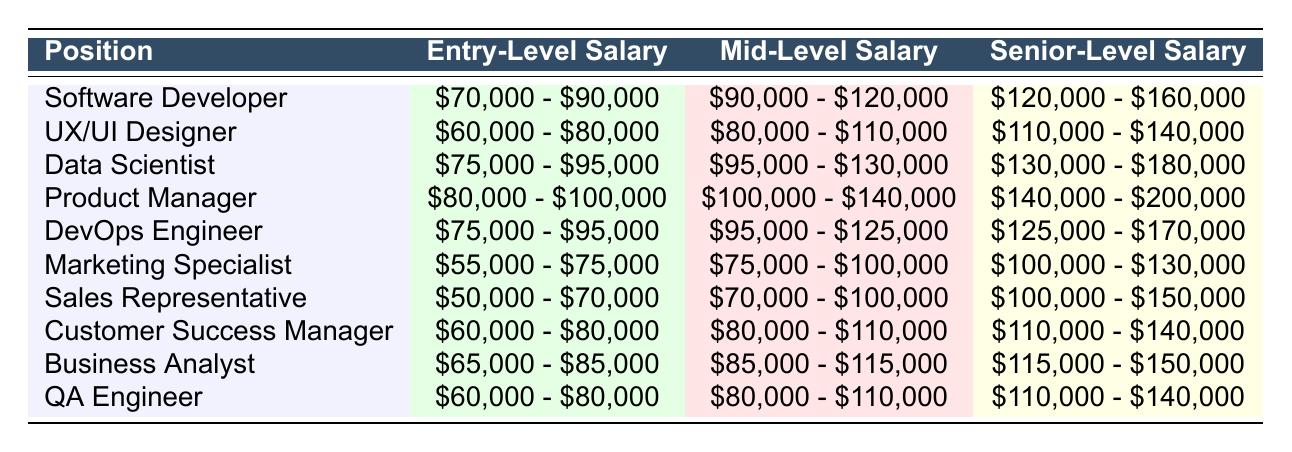What is the entry-level salary range for a Data Scientist? The table lists the salaries for each position. For Data Scientist, the entry-level salary is indicated as $75,000 - $95,000.
Answer: $75,000 - $95,000 Which position has the highest senior-level salary range? By examining the senior-level salary ranges, Product Manager has the highest range at $140,000 - $200,000.
Answer: Product Manager What is the difference in mid-level salary between a Software Developer and a Marketing Specialist? The mid-level salary for a Software Developer is $90,000 - $120,000, and for a Marketing Specialist, it is $75,000 - $100,000. The difference between the upper limits is $120,000 - $100,000 = $20,000.
Answer: $20,000 Is the entry-level salary of a Sales Representative higher than that of a Marketing Specialist? The entry-level salary for a Sales Representative is $50,000 - $70,000 and for a Marketing Specialist, it is $55,000 - $75,000. Since $50,000 - $70,000 is lower than $55,000 - $75,000, the answer is no.
Answer: No What is the average salary range of a QA Engineer across all levels? For QA Engineer, the entry-level is $60,000 - $80,000, mid-level is $80,000 - $110,000, and senior-level is $110,000 - $140,000. The average of the low ends is ($60,000 + $80,000 + $110,000)/3 = $83,333.33 and for the high ends is ($80,000 + $110,000 + $140,000)/3 = $110,000. Therefore, the average range is approximately $83,333.33 - $110,000.
Answer: $83,333.33 - $110,000 Which position has a higher mid-level salary: Data Scientist or Product Manager? Comparing the mid-level salaries, Data Scientist is $95,000 - $130,000, while Product Manager is $100,000 - $140,000. Since $100,000 - $140,000 starts at a higher figure, Product Manager has a higher mid-level salary.
Answer: Product Manager How many positions have an entry-level salary range starting below $60,000? From the entry-level salary figures, only the Sales Representative position starts at $50,000. Thus, there is only one position that has an entry-level salary range starting below $60,000.
Answer: 1 What is the combined senior-level salary range for a DevOps Engineer and a Data Scientist? The senior-level salary for a DevOps Engineer is $125,000 - $170,000, and for a Data Scientist, it is $130,000 - $180,000. Therefore, the combined ranges can be stated as $125,000 - $170,000 and $130,000 - $180,000, respectively. To express it in an overall range would yield $125,000 - $180,000.
Answer: $125,000 - $180,000 Which two positions have the closest entry-level salary ranges? By analyzing the entry-level salary ranges, we find that the ranges for UX/UI Designer ($60,000 - $80,000) and QA Engineer ($60,000 - $80,000) are identical. Therefore, they have the closest entry-level salary ranges.
Answer: UX/UI Designer and QA Engineer 